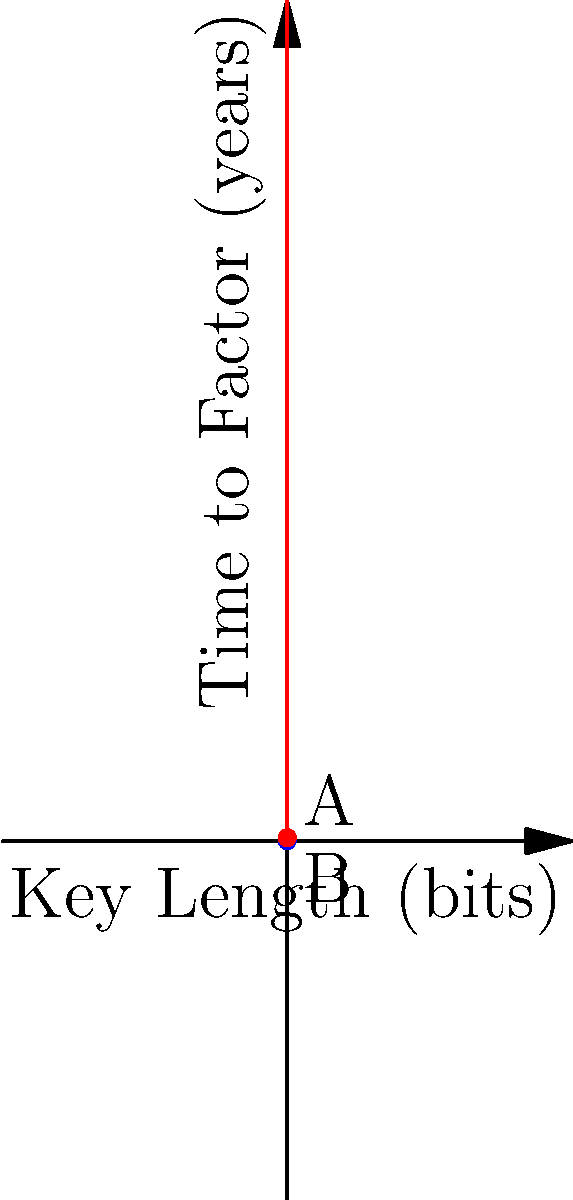Given the graph representing the time complexity of factoring encryption keys of different lengths, what is the approximate difference in years between points A and B for a 5-bit key length, assuming the blue curve represents $2^n$ and the red curve represents $3^n$? How does this relate to the security of encryption keys in a corporate network? To solve this problem, we need to follow these steps:

1) Identify the functions:
   Blue curve: $f(n) = 2^n$
   Red curve: $g(n) = 3^n$

2) Calculate the values for a 5-bit key:
   Point A (blue curve): $f(5) = 2^5 = 32$ years
   Point B (red curve): $g(5) = 3^5 = 243$ years

3) Calculate the difference:
   Difference = $g(5) - f(5) = 243 - 32 = 211$ years

4) Relating to network security:
   This difference illustrates the significant impact of the base in exponential growth. In encryption, larger bases and longer key lengths exponentially increase the time required for brute-force attacks. For a corporate network, this means:

   a) Choosing algorithms with larger bases (like 3 instead of 2) can significantly increase security.
   b) Small increases in key length result in large increases in factoring time, enhancing security.
   c) Regular key rotation becomes crucial, as computational power increases over time.
   d) Balancing security (longer keys) with performance (shorter keys) is essential for efficient network operations.
Answer: 211 years; exponential increase in factoring time with key complexity enhances network security. 